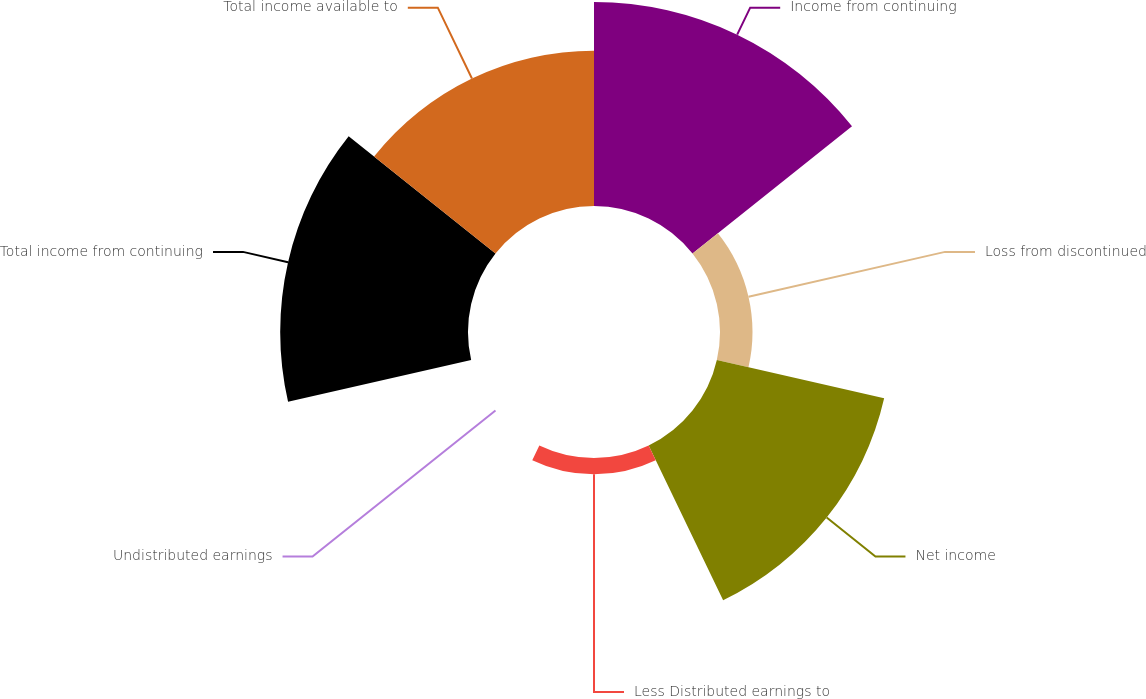Convert chart. <chart><loc_0><loc_0><loc_500><loc_500><pie_chart><fcel>Income from continuing<fcel>Loss from discontinued<fcel>Net income<fcel>Less Distributed earnings to<fcel>Undistributed earnings<fcel>Total income from continuing<fcel>Total income available to<nl><fcel>26.58%<fcel>4.23%<fcel>22.36%<fcel>2.12%<fcel>0.0%<fcel>24.47%<fcel>20.24%<nl></chart> 